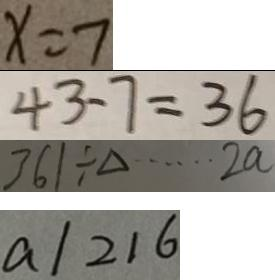<formula> <loc_0><loc_0><loc_500><loc_500>x = 7 
 4 3 - 7 = 3 6 
 3 6 1 \div \Delta \cdots 2 a 
 a / 2 1 6</formula> 